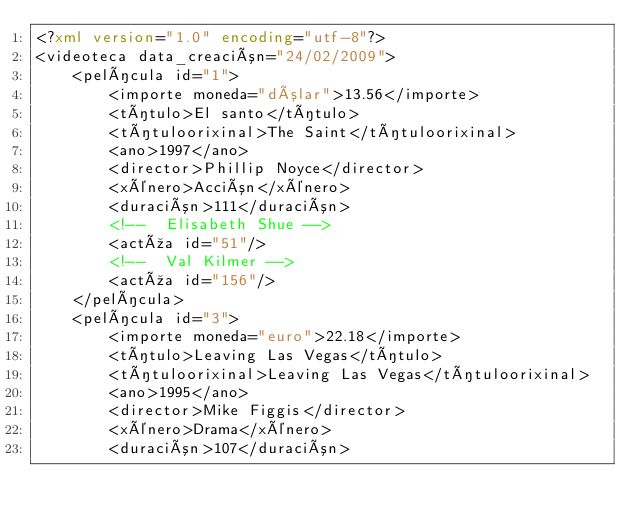Convert code to text. <code><loc_0><loc_0><loc_500><loc_500><_XML_><?xml version="1.0" encoding="utf-8"?>
<videoteca data_creación="24/02/2009">
	<película id="1">
		<importe moneda="dólar">13.56</importe>
		<título>El santo</título>
		<títuloorixinal>The Saint</títuloorixinal>
		<ano>1997</ano>
		<director>Phillip Noyce</director>
		<xénero>Acción</xénero>
		<duración>111</duración>
		<!--  Elisabeth Shue -->
		<actúa id="51"/>
		<!--  Val Kilmer -->
		<actúa id="156"/>
	</película>
	<película id="3">
		<importe moneda="euro">22.18</importe>
		<título>Leaving Las Vegas</título>
		<títuloorixinal>Leaving Las Vegas</títuloorixinal>
		<ano>1995</ano>
		<director>Mike Figgis</director>
		<xénero>Drama</xénero>
		<duración>107</duración></code> 